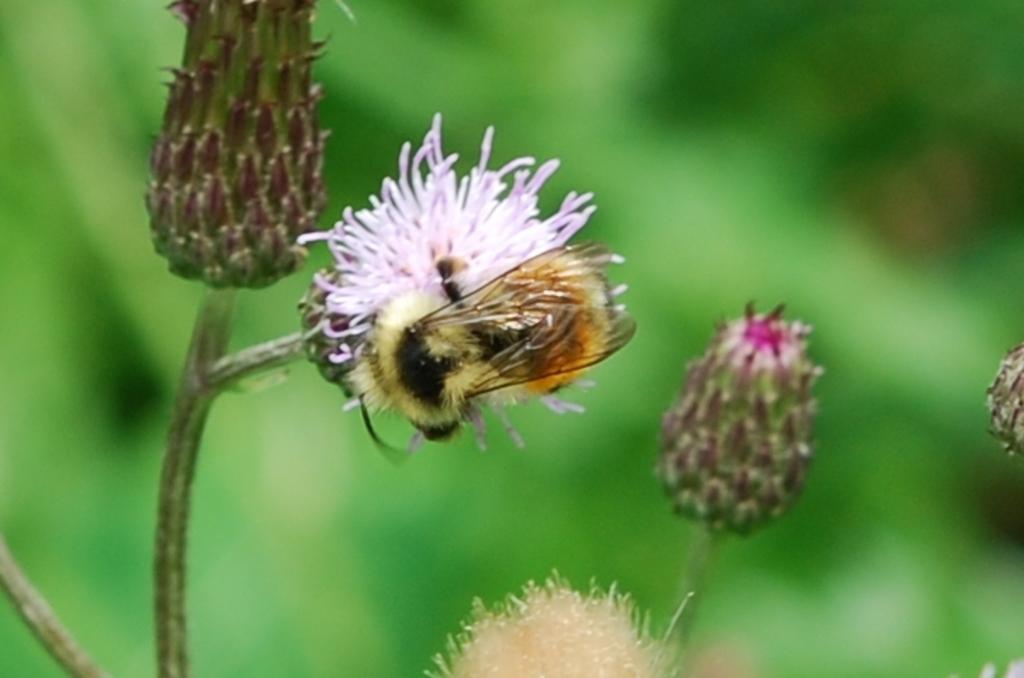How would you summarize this image in a sentence or two? In this image, we can see a honey bee on the flower. Here we can see few flowers with stem. Background we can see a blur view. 